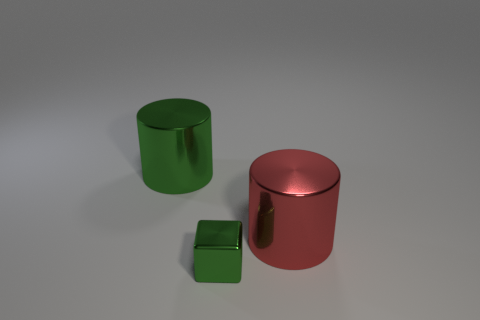What is the red thing made of?
Your answer should be compact. Metal. What number of large red cylinders are behind the red metallic thing?
Your response must be concise. 0. How many large objects are the same color as the small metallic cube?
Your response must be concise. 1. Are there more green metallic cylinders than big cylinders?
Your answer should be compact. No. How big is the shiny object that is behind the green cube and to the left of the big red metal object?
Offer a terse response. Large. Do the green thing on the left side of the tiny shiny object and the large thing that is to the right of the tiny green shiny thing have the same material?
Ensure brevity in your answer.  Yes. Is the number of small green metal things less than the number of big metal cylinders?
Your response must be concise. Yes. Is there a tiny metallic thing to the right of the big metallic thing left of the red thing?
Give a very brief answer. Yes. Are there any metallic cylinders that are to the right of the green shiny thing in front of the shiny cylinder to the right of the tiny metallic object?
Provide a short and direct response. Yes. Do the big metallic thing that is left of the tiny green cube and the green object in front of the large green metallic object have the same shape?
Keep it short and to the point. No. 